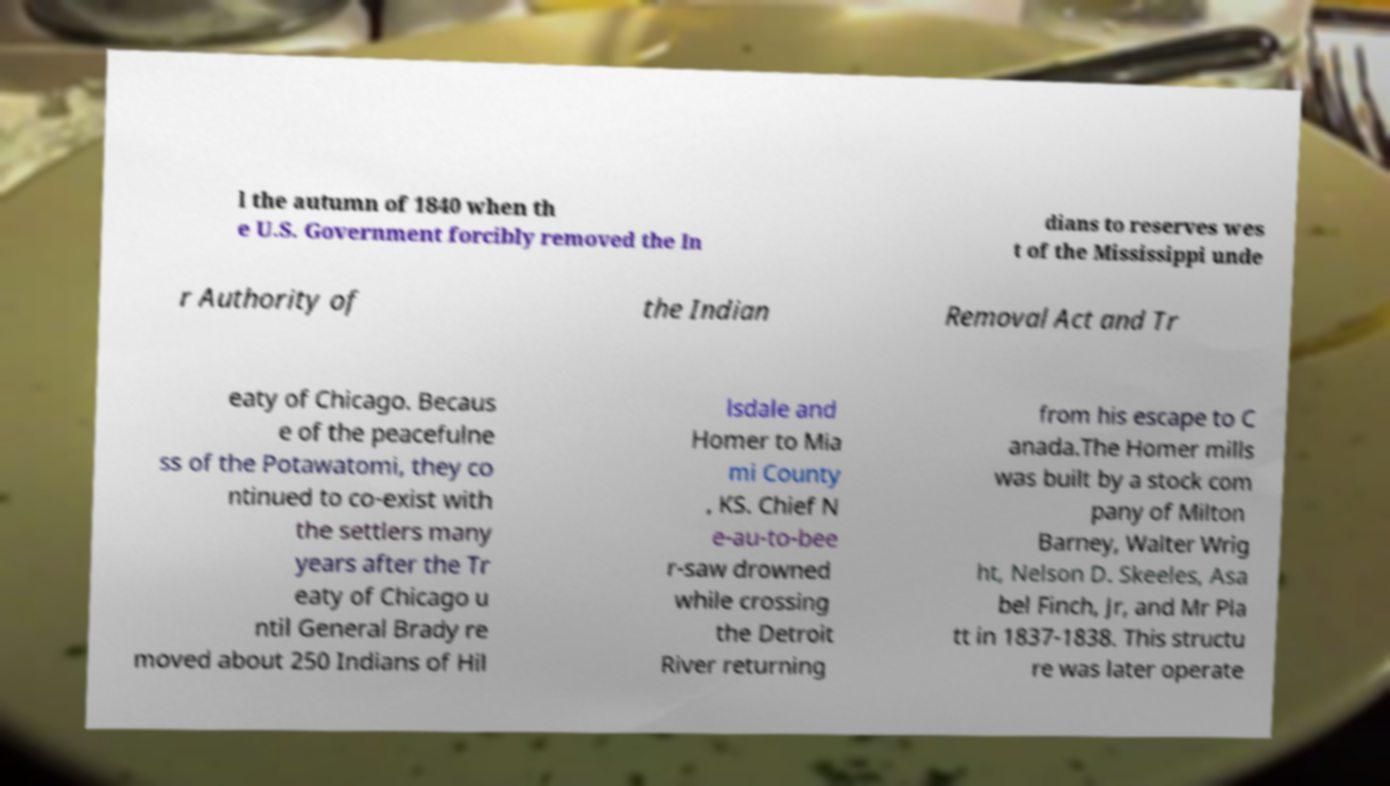Could you extract and type out the text from this image? l the autumn of 1840 when th e U.S. Government forcibly removed the In dians to reserves wes t of the Mississippi unde r Authority of the Indian Removal Act and Tr eaty of Chicago. Becaus e of the peacefulne ss of the Potawatomi, they co ntinued to co-exist with the settlers many years after the Tr eaty of Chicago u ntil General Brady re moved about 250 Indians of Hil lsdale and Homer to Mia mi County , KS. Chief N e-au-to-bee r-saw drowned while crossing the Detroit River returning from his escape to C anada.The Homer mills was built by a stock com pany of Milton Barney, Walter Wrig ht, Nelson D. Skeeles, Asa bel Finch, Jr, and Mr Pla tt in 1837-1838. This structu re was later operate 